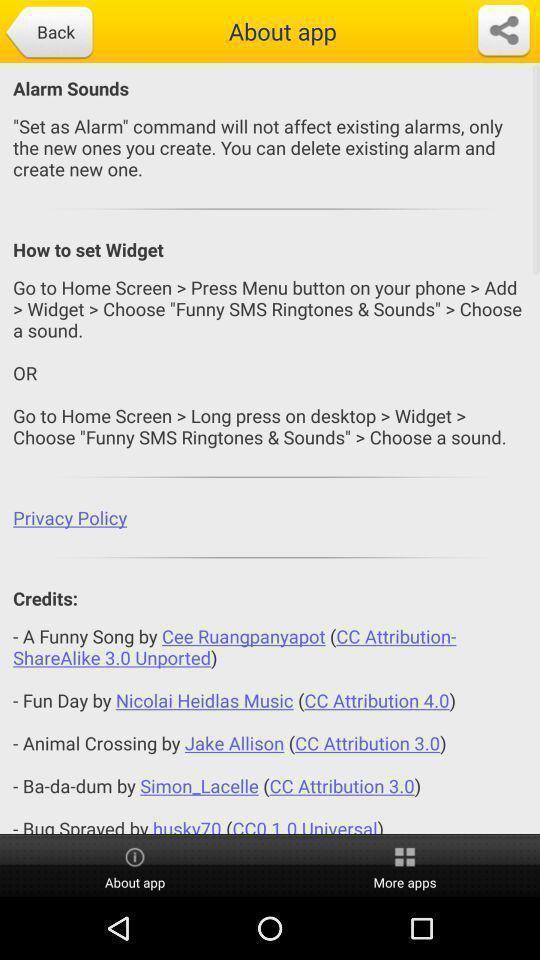Describe the visual elements of this screenshot. Page is displaying about. 